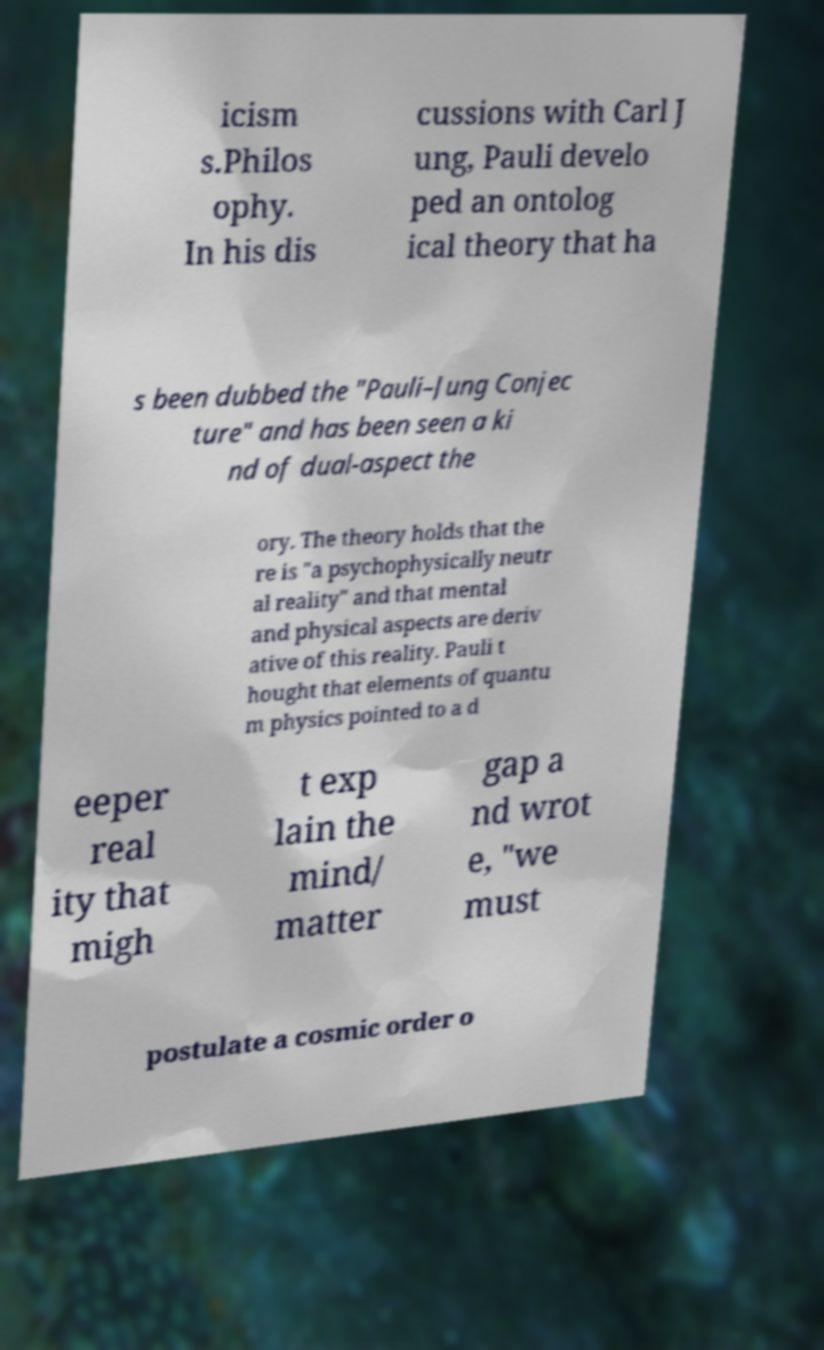Could you assist in decoding the text presented in this image and type it out clearly? icism s.Philos ophy. In his dis cussions with Carl J ung, Pauli develo ped an ontolog ical theory that ha s been dubbed the "Pauli–Jung Conjec ture" and has been seen a ki nd of dual-aspect the ory. The theory holds that the re is "a psychophysically neutr al reality" and that mental and physical aspects are deriv ative of this reality. Pauli t hought that elements of quantu m physics pointed to a d eeper real ity that migh t exp lain the mind/ matter gap a nd wrot e, "we must postulate a cosmic order o 